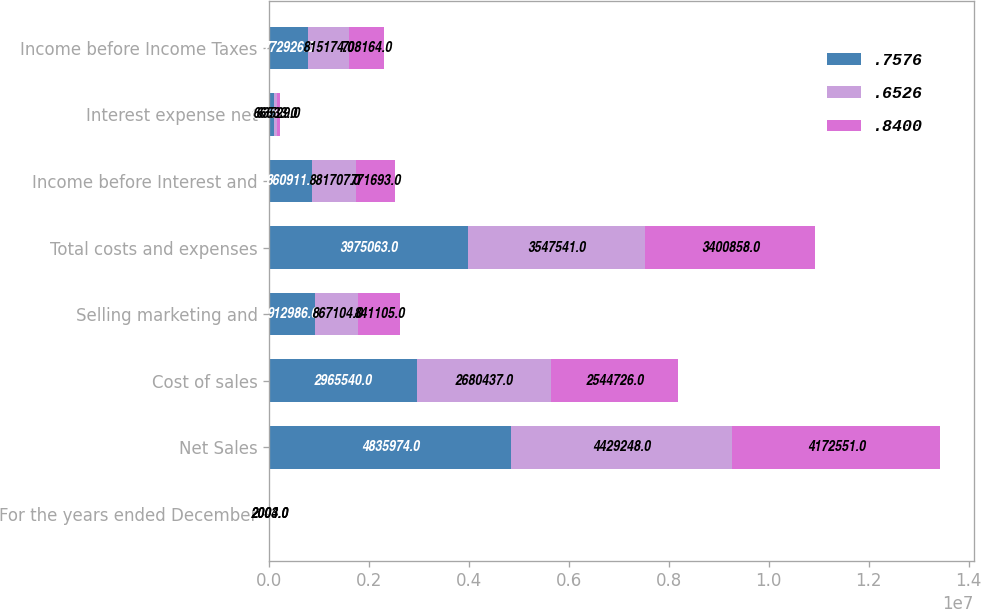Convert chart to OTSL. <chart><loc_0><loc_0><loc_500><loc_500><stacked_bar_chart><ecel><fcel>For the years ended December<fcel>Net Sales<fcel>Cost of sales<fcel>Selling marketing and<fcel>Total costs and expenses<fcel>Income before Interest and<fcel>Interest expense net<fcel>Income before Income Taxes<nl><fcel>0.7576<fcel>2005<fcel>4.83597e+06<fcel>2.96554e+06<fcel>912986<fcel>3.97506e+06<fcel>860911<fcel>87985<fcel>772926<nl><fcel>0.6526<fcel>2004<fcel>4.42925e+06<fcel>2.68044e+06<fcel>867104<fcel>3.54754e+06<fcel>881707<fcel>66533<fcel>815174<nl><fcel>0.84<fcel>2003<fcel>4.17255e+06<fcel>2.54473e+06<fcel>841105<fcel>3.40086e+06<fcel>771693<fcel>63529<fcel>708164<nl></chart> 